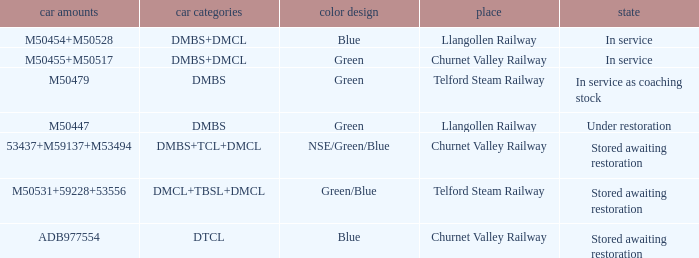What status is the vehicle numbers of adb977554? Stored awaiting restoration. 